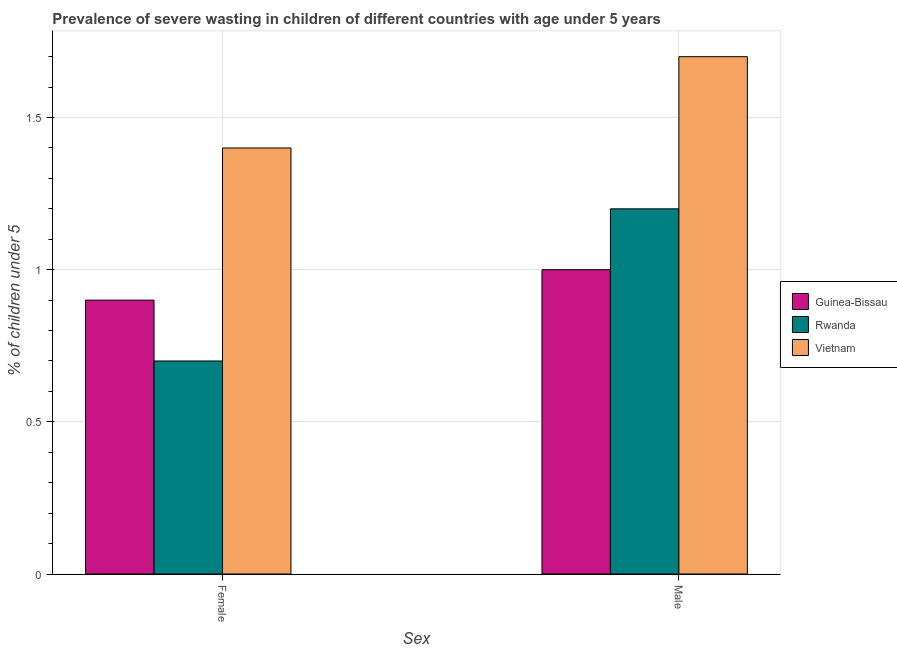How many groups of bars are there?
Give a very brief answer. 2. How many bars are there on the 2nd tick from the right?
Your answer should be very brief. 3. What is the percentage of undernourished male children in Vietnam?
Your response must be concise. 1.7. Across all countries, what is the maximum percentage of undernourished female children?
Give a very brief answer. 1.4. Across all countries, what is the minimum percentage of undernourished female children?
Offer a very short reply. 0.7. In which country was the percentage of undernourished female children maximum?
Your answer should be very brief. Vietnam. In which country was the percentage of undernourished male children minimum?
Provide a short and direct response. Guinea-Bissau. What is the total percentage of undernourished male children in the graph?
Provide a short and direct response. 3.9. What is the difference between the percentage of undernourished male children in Guinea-Bissau and that in Vietnam?
Provide a short and direct response. -0.7. What is the difference between the percentage of undernourished male children in Rwanda and the percentage of undernourished female children in Guinea-Bissau?
Your response must be concise. 0.3. What is the average percentage of undernourished female children per country?
Give a very brief answer. 1. What is the difference between the percentage of undernourished male children and percentage of undernourished female children in Vietnam?
Your answer should be compact. 0.3. What is the ratio of the percentage of undernourished female children in Vietnam to that in Rwanda?
Your answer should be compact. 2. What does the 2nd bar from the left in Male represents?
Keep it short and to the point. Rwanda. What does the 2nd bar from the right in Female represents?
Provide a succinct answer. Rwanda. How many bars are there?
Your response must be concise. 6. What is the difference between two consecutive major ticks on the Y-axis?
Provide a succinct answer. 0.5. Are the values on the major ticks of Y-axis written in scientific E-notation?
Make the answer very short. No. Does the graph contain grids?
Your answer should be compact. Yes. What is the title of the graph?
Your answer should be very brief. Prevalence of severe wasting in children of different countries with age under 5 years. What is the label or title of the X-axis?
Your response must be concise. Sex. What is the label or title of the Y-axis?
Provide a short and direct response.  % of children under 5. What is the  % of children under 5 in Guinea-Bissau in Female?
Offer a terse response. 0.9. What is the  % of children under 5 in Rwanda in Female?
Offer a very short reply. 0.7. What is the  % of children under 5 in Vietnam in Female?
Your answer should be very brief. 1.4. What is the  % of children under 5 of Rwanda in Male?
Keep it short and to the point. 1.2. What is the  % of children under 5 in Vietnam in Male?
Provide a short and direct response. 1.7. Across all Sex, what is the maximum  % of children under 5 of Guinea-Bissau?
Offer a terse response. 1. Across all Sex, what is the maximum  % of children under 5 in Rwanda?
Give a very brief answer. 1.2. Across all Sex, what is the maximum  % of children under 5 of Vietnam?
Give a very brief answer. 1.7. Across all Sex, what is the minimum  % of children under 5 in Guinea-Bissau?
Keep it short and to the point. 0.9. Across all Sex, what is the minimum  % of children under 5 in Rwanda?
Offer a very short reply. 0.7. Across all Sex, what is the minimum  % of children under 5 of Vietnam?
Keep it short and to the point. 1.4. What is the total  % of children under 5 in Guinea-Bissau in the graph?
Keep it short and to the point. 1.9. What is the total  % of children under 5 of Rwanda in the graph?
Your response must be concise. 1.9. What is the total  % of children under 5 of Vietnam in the graph?
Your answer should be very brief. 3.1. What is the difference between the  % of children under 5 in Vietnam in Female and that in Male?
Give a very brief answer. -0.3. What is the difference between the  % of children under 5 in Guinea-Bissau in Female and the  % of children under 5 in Rwanda in Male?
Provide a short and direct response. -0.3. What is the difference between the  % of children under 5 in Guinea-Bissau in Female and the  % of children under 5 in Vietnam in Male?
Give a very brief answer. -0.8. What is the difference between the  % of children under 5 of Rwanda in Female and the  % of children under 5 of Vietnam in Male?
Your answer should be very brief. -1. What is the average  % of children under 5 in Guinea-Bissau per Sex?
Provide a short and direct response. 0.95. What is the average  % of children under 5 in Vietnam per Sex?
Give a very brief answer. 1.55. What is the difference between the  % of children under 5 of Guinea-Bissau and  % of children under 5 of Rwanda in Female?
Your answer should be very brief. 0.2. What is the difference between the  % of children under 5 of Rwanda and  % of children under 5 of Vietnam in Female?
Make the answer very short. -0.7. What is the difference between the  % of children under 5 of Guinea-Bissau and  % of children under 5 of Rwanda in Male?
Your answer should be very brief. -0.2. What is the ratio of the  % of children under 5 in Rwanda in Female to that in Male?
Keep it short and to the point. 0.58. What is the ratio of the  % of children under 5 in Vietnam in Female to that in Male?
Provide a succinct answer. 0.82. What is the difference between the highest and the second highest  % of children under 5 of Guinea-Bissau?
Offer a very short reply. 0.1. What is the difference between the highest and the second highest  % of children under 5 in Vietnam?
Your answer should be compact. 0.3. What is the difference between the highest and the lowest  % of children under 5 of Guinea-Bissau?
Ensure brevity in your answer.  0.1. What is the difference between the highest and the lowest  % of children under 5 in Rwanda?
Your answer should be compact. 0.5. 